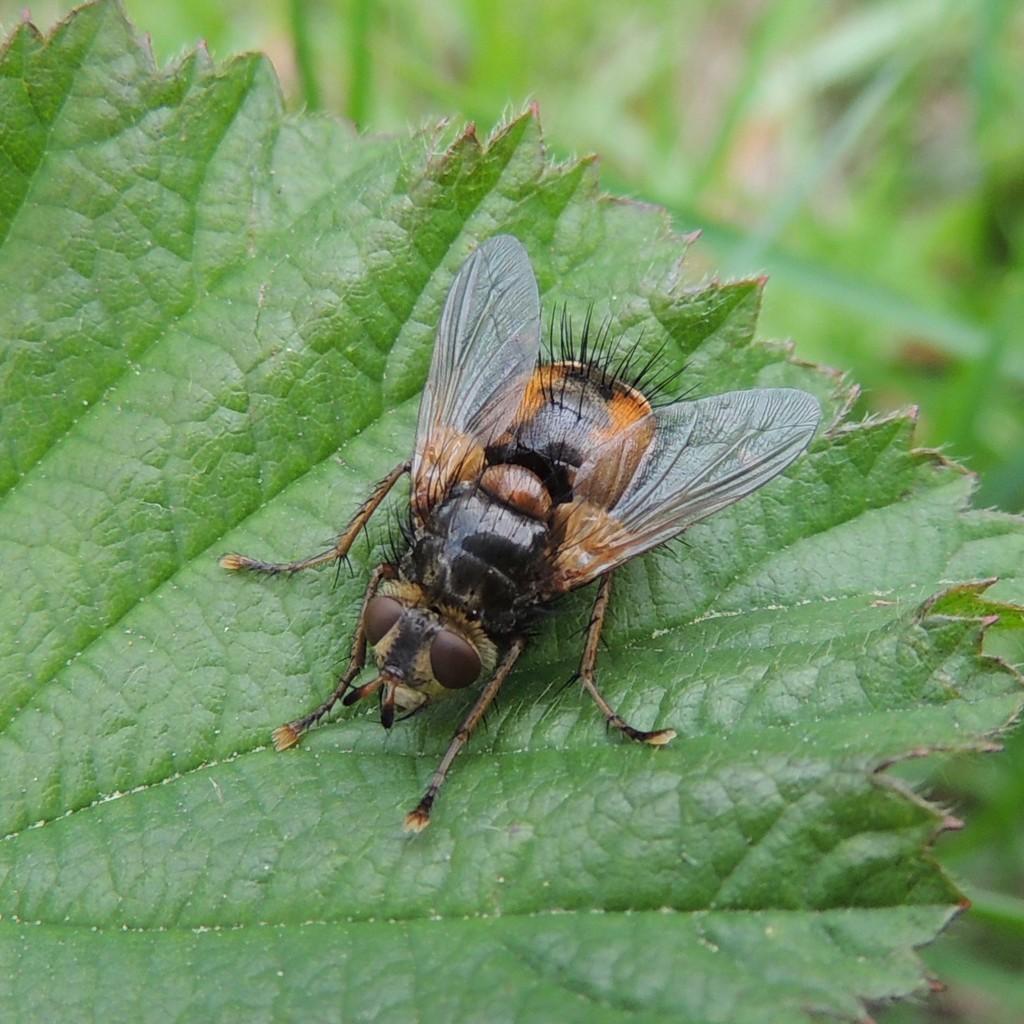Describe this image in one or two sentences. In this image we can see an insect on the leaf and the background is blurred. 